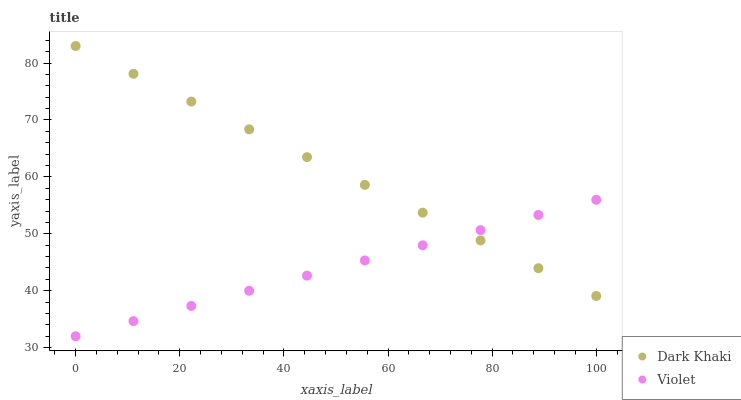Does Violet have the minimum area under the curve?
Answer yes or no. Yes. Does Dark Khaki have the maximum area under the curve?
Answer yes or no. Yes. Does Violet have the maximum area under the curve?
Answer yes or no. No. Is Violet the smoothest?
Answer yes or no. Yes. Is Dark Khaki the roughest?
Answer yes or no. Yes. Is Violet the roughest?
Answer yes or no. No. Does Violet have the lowest value?
Answer yes or no. Yes. Does Dark Khaki have the highest value?
Answer yes or no. Yes. Does Violet have the highest value?
Answer yes or no. No. Does Dark Khaki intersect Violet?
Answer yes or no. Yes. Is Dark Khaki less than Violet?
Answer yes or no. No. Is Dark Khaki greater than Violet?
Answer yes or no. No. 